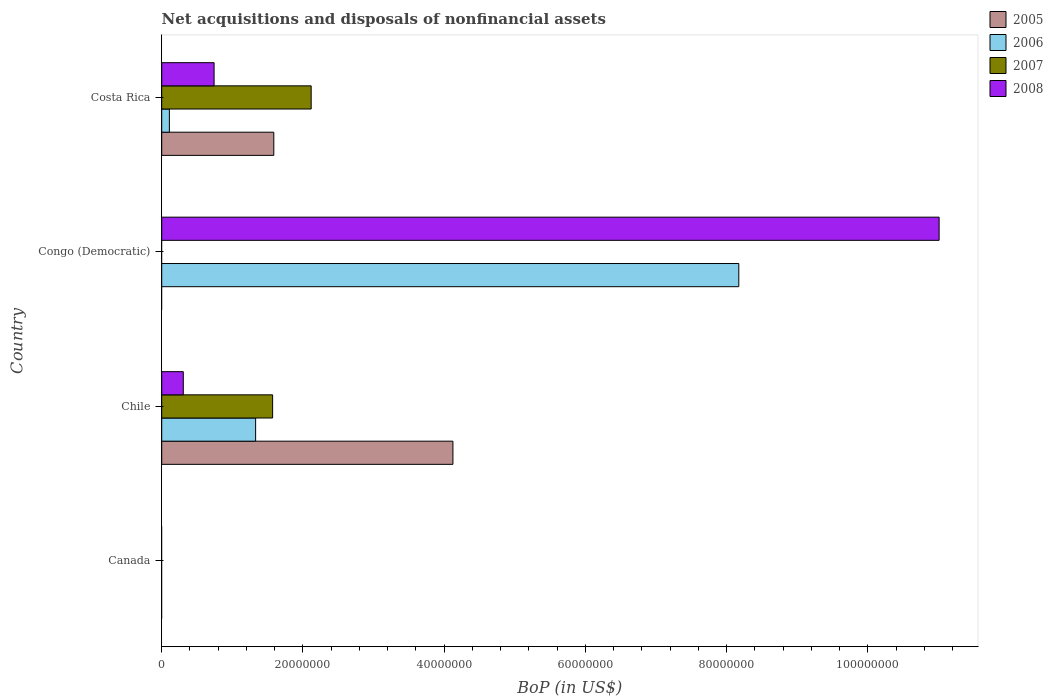How many different coloured bars are there?
Keep it short and to the point. 4. Are the number of bars per tick equal to the number of legend labels?
Ensure brevity in your answer.  No. How many bars are there on the 2nd tick from the top?
Provide a short and direct response. 2. How many bars are there on the 2nd tick from the bottom?
Provide a succinct answer. 4. What is the label of the 3rd group of bars from the top?
Provide a succinct answer. Chile. What is the Balance of Payments in 2005 in Canada?
Make the answer very short. 0. Across all countries, what is the maximum Balance of Payments in 2006?
Keep it short and to the point. 8.17e+07. Across all countries, what is the minimum Balance of Payments in 2005?
Ensure brevity in your answer.  0. In which country was the Balance of Payments in 2005 maximum?
Offer a terse response. Chile. What is the total Balance of Payments in 2008 in the graph?
Your answer should be compact. 1.21e+08. What is the difference between the Balance of Payments in 2006 in Congo (Democratic) and that in Costa Rica?
Ensure brevity in your answer.  8.06e+07. What is the difference between the Balance of Payments in 2006 in Congo (Democratic) and the Balance of Payments in 2005 in Costa Rica?
Provide a succinct answer. 6.59e+07. What is the average Balance of Payments in 2008 per country?
Provide a short and direct response. 3.01e+07. What is the difference between the Balance of Payments in 2005 and Balance of Payments in 2007 in Chile?
Give a very brief answer. 2.55e+07. In how many countries, is the Balance of Payments in 2005 greater than 76000000 US$?
Offer a very short reply. 0. Is the Balance of Payments in 2006 in Chile less than that in Congo (Democratic)?
Ensure brevity in your answer.  Yes. Is the difference between the Balance of Payments in 2005 in Chile and Costa Rica greater than the difference between the Balance of Payments in 2007 in Chile and Costa Rica?
Ensure brevity in your answer.  Yes. What is the difference between the highest and the second highest Balance of Payments in 2008?
Provide a short and direct response. 1.03e+08. What is the difference between the highest and the lowest Balance of Payments in 2006?
Your answer should be compact. 8.17e+07. Is the sum of the Balance of Payments in 2007 in Chile and Costa Rica greater than the maximum Balance of Payments in 2008 across all countries?
Ensure brevity in your answer.  No. Is it the case that in every country, the sum of the Balance of Payments in 2006 and Balance of Payments in 2007 is greater than the sum of Balance of Payments in 2005 and Balance of Payments in 2008?
Offer a terse response. No. Are all the bars in the graph horizontal?
Make the answer very short. Yes. How many countries are there in the graph?
Offer a very short reply. 4. What is the difference between two consecutive major ticks on the X-axis?
Offer a very short reply. 2.00e+07. Are the values on the major ticks of X-axis written in scientific E-notation?
Keep it short and to the point. No. Where does the legend appear in the graph?
Your response must be concise. Top right. How many legend labels are there?
Provide a short and direct response. 4. What is the title of the graph?
Offer a terse response. Net acquisitions and disposals of nonfinancial assets. What is the label or title of the X-axis?
Ensure brevity in your answer.  BoP (in US$). What is the BoP (in US$) of 2005 in Canada?
Keep it short and to the point. 0. What is the BoP (in US$) of 2008 in Canada?
Make the answer very short. 0. What is the BoP (in US$) of 2005 in Chile?
Your response must be concise. 4.12e+07. What is the BoP (in US$) in 2006 in Chile?
Make the answer very short. 1.33e+07. What is the BoP (in US$) in 2007 in Chile?
Your answer should be very brief. 1.57e+07. What is the BoP (in US$) in 2008 in Chile?
Provide a short and direct response. 3.06e+06. What is the BoP (in US$) in 2006 in Congo (Democratic)?
Ensure brevity in your answer.  8.17e+07. What is the BoP (in US$) in 2008 in Congo (Democratic)?
Your response must be concise. 1.10e+08. What is the BoP (in US$) in 2005 in Costa Rica?
Provide a short and direct response. 1.59e+07. What is the BoP (in US$) in 2006 in Costa Rica?
Provide a short and direct response. 1.09e+06. What is the BoP (in US$) of 2007 in Costa Rica?
Your answer should be very brief. 2.12e+07. What is the BoP (in US$) of 2008 in Costa Rica?
Your response must be concise. 7.42e+06. Across all countries, what is the maximum BoP (in US$) in 2005?
Offer a terse response. 4.12e+07. Across all countries, what is the maximum BoP (in US$) in 2006?
Your response must be concise. 8.17e+07. Across all countries, what is the maximum BoP (in US$) in 2007?
Your answer should be compact. 2.12e+07. Across all countries, what is the maximum BoP (in US$) in 2008?
Provide a succinct answer. 1.10e+08. Across all countries, what is the minimum BoP (in US$) in 2005?
Offer a terse response. 0. Across all countries, what is the minimum BoP (in US$) in 2006?
Offer a very short reply. 0. Across all countries, what is the minimum BoP (in US$) in 2007?
Give a very brief answer. 0. Across all countries, what is the minimum BoP (in US$) in 2008?
Provide a succinct answer. 0. What is the total BoP (in US$) of 2005 in the graph?
Your answer should be compact. 5.71e+07. What is the total BoP (in US$) of 2006 in the graph?
Make the answer very short. 9.61e+07. What is the total BoP (in US$) of 2007 in the graph?
Offer a terse response. 3.69e+07. What is the total BoP (in US$) of 2008 in the graph?
Make the answer very short. 1.21e+08. What is the difference between the BoP (in US$) of 2006 in Chile and that in Congo (Democratic)?
Offer a very short reply. -6.84e+07. What is the difference between the BoP (in US$) of 2008 in Chile and that in Congo (Democratic)?
Make the answer very short. -1.07e+08. What is the difference between the BoP (in US$) of 2005 in Chile and that in Costa Rica?
Keep it short and to the point. 2.54e+07. What is the difference between the BoP (in US$) in 2006 in Chile and that in Costa Rica?
Your answer should be compact. 1.22e+07. What is the difference between the BoP (in US$) in 2007 in Chile and that in Costa Rica?
Make the answer very short. -5.46e+06. What is the difference between the BoP (in US$) of 2008 in Chile and that in Costa Rica?
Offer a very short reply. -4.36e+06. What is the difference between the BoP (in US$) in 2006 in Congo (Democratic) and that in Costa Rica?
Your response must be concise. 8.06e+07. What is the difference between the BoP (in US$) in 2008 in Congo (Democratic) and that in Costa Rica?
Offer a terse response. 1.03e+08. What is the difference between the BoP (in US$) in 2005 in Chile and the BoP (in US$) in 2006 in Congo (Democratic)?
Offer a very short reply. -4.05e+07. What is the difference between the BoP (in US$) of 2005 in Chile and the BoP (in US$) of 2008 in Congo (Democratic)?
Provide a short and direct response. -6.89e+07. What is the difference between the BoP (in US$) in 2006 in Chile and the BoP (in US$) in 2008 in Congo (Democratic)?
Make the answer very short. -9.68e+07. What is the difference between the BoP (in US$) in 2007 in Chile and the BoP (in US$) in 2008 in Congo (Democratic)?
Your answer should be compact. -9.44e+07. What is the difference between the BoP (in US$) in 2005 in Chile and the BoP (in US$) in 2006 in Costa Rica?
Offer a very short reply. 4.02e+07. What is the difference between the BoP (in US$) in 2005 in Chile and the BoP (in US$) in 2007 in Costa Rica?
Keep it short and to the point. 2.01e+07. What is the difference between the BoP (in US$) in 2005 in Chile and the BoP (in US$) in 2008 in Costa Rica?
Provide a succinct answer. 3.38e+07. What is the difference between the BoP (in US$) of 2006 in Chile and the BoP (in US$) of 2007 in Costa Rica?
Provide a succinct answer. -7.87e+06. What is the difference between the BoP (in US$) of 2006 in Chile and the BoP (in US$) of 2008 in Costa Rica?
Ensure brevity in your answer.  5.88e+06. What is the difference between the BoP (in US$) in 2007 in Chile and the BoP (in US$) in 2008 in Costa Rica?
Make the answer very short. 8.29e+06. What is the difference between the BoP (in US$) in 2006 in Congo (Democratic) and the BoP (in US$) in 2007 in Costa Rica?
Keep it short and to the point. 6.06e+07. What is the difference between the BoP (in US$) in 2006 in Congo (Democratic) and the BoP (in US$) in 2008 in Costa Rica?
Offer a terse response. 7.43e+07. What is the average BoP (in US$) in 2005 per country?
Ensure brevity in your answer.  1.43e+07. What is the average BoP (in US$) in 2006 per country?
Provide a succinct answer. 2.40e+07. What is the average BoP (in US$) in 2007 per country?
Make the answer very short. 9.22e+06. What is the average BoP (in US$) in 2008 per country?
Ensure brevity in your answer.  3.01e+07. What is the difference between the BoP (in US$) in 2005 and BoP (in US$) in 2006 in Chile?
Give a very brief answer. 2.79e+07. What is the difference between the BoP (in US$) in 2005 and BoP (in US$) in 2007 in Chile?
Offer a very short reply. 2.55e+07. What is the difference between the BoP (in US$) in 2005 and BoP (in US$) in 2008 in Chile?
Ensure brevity in your answer.  3.82e+07. What is the difference between the BoP (in US$) in 2006 and BoP (in US$) in 2007 in Chile?
Your answer should be compact. -2.41e+06. What is the difference between the BoP (in US$) in 2006 and BoP (in US$) in 2008 in Chile?
Make the answer very short. 1.02e+07. What is the difference between the BoP (in US$) in 2007 and BoP (in US$) in 2008 in Chile?
Offer a terse response. 1.27e+07. What is the difference between the BoP (in US$) in 2006 and BoP (in US$) in 2008 in Congo (Democratic)?
Provide a succinct answer. -2.84e+07. What is the difference between the BoP (in US$) in 2005 and BoP (in US$) in 2006 in Costa Rica?
Your response must be concise. 1.48e+07. What is the difference between the BoP (in US$) of 2005 and BoP (in US$) of 2007 in Costa Rica?
Provide a short and direct response. -5.29e+06. What is the difference between the BoP (in US$) of 2005 and BoP (in US$) of 2008 in Costa Rica?
Your answer should be compact. 8.45e+06. What is the difference between the BoP (in US$) in 2006 and BoP (in US$) in 2007 in Costa Rica?
Offer a terse response. -2.01e+07. What is the difference between the BoP (in US$) of 2006 and BoP (in US$) of 2008 in Costa Rica?
Your response must be concise. -6.33e+06. What is the difference between the BoP (in US$) of 2007 and BoP (in US$) of 2008 in Costa Rica?
Offer a terse response. 1.37e+07. What is the ratio of the BoP (in US$) in 2006 in Chile to that in Congo (Democratic)?
Ensure brevity in your answer.  0.16. What is the ratio of the BoP (in US$) of 2008 in Chile to that in Congo (Democratic)?
Provide a short and direct response. 0.03. What is the ratio of the BoP (in US$) in 2005 in Chile to that in Costa Rica?
Your answer should be very brief. 2.6. What is the ratio of the BoP (in US$) of 2006 in Chile to that in Costa Rica?
Make the answer very short. 12.25. What is the ratio of the BoP (in US$) of 2007 in Chile to that in Costa Rica?
Ensure brevity in your answer.  0.74. What is the ratio of the BoP (in US$) in 2008 in Chile to that in Costa Rica?
Your response must be concise. 0.41. What is the ratio of the BoP (in US$) of 2006 in Congo (Democratic) to that in Costa Rica?
Make the answer very short. 75.27. What is the ratio of the BoP (in US$) of 2008 in Congo (Democratic) to that in Costa Rica?
Provide a short and direct response. 14.84. What is the difference between the highest and the second highest BoP (in US$) in 2006?
Provide a short and direct response. 6.84e+07. What is the difference between the highest and the second highest BoP (in US$) of 2008?
Offer a very short reply. 1.03e+08. What is the difference between the highest and the lowest BoP (in US$) in 2005?
Your answer should be very brief. 4.12e+07. What is the difference between the highest and the lowest BoP (in US$) of 2006?
Make the answer very short. 8.17e+07. What is the difference between the highest and the lowest BoP (in US$) in 2007?
Offer a terse response. 2.12e+07. What is the difference between the highest and the lowest BoP (in US$) in 2008?
Ensure brevity in your answer.  1.10e+08. 